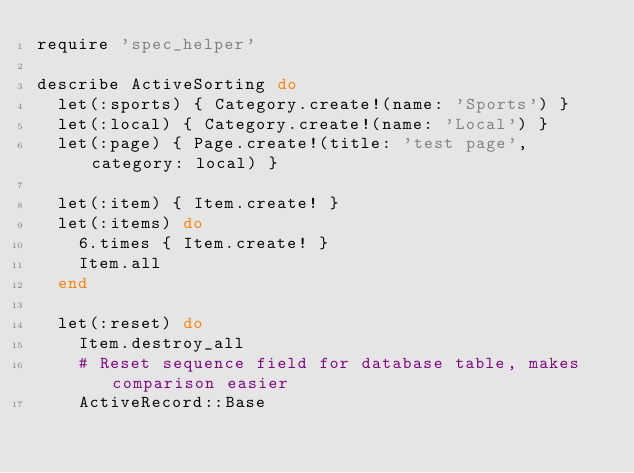Convert code to text. <code><loc_0><loc_0><loc_500><loc_500><_Ruby_>require 'spec_helper'

describe ActiveSorting do
  let(:sports) { Category.create!(name: 'Sports') }
  let(:local) { Category.create!(name: 'Local') }
  let(:page) { Page.create!(title: 'test page', category: local) }

  let(:item) { Item.create! }
  let(:items) do
    6.times { Item.create! }
    Item.all
  end

  let(:reset) do
    Item.destroy_all
    # Reset sequence field for database table, makes comparison easier
    ActiveRecord::Base</code> 